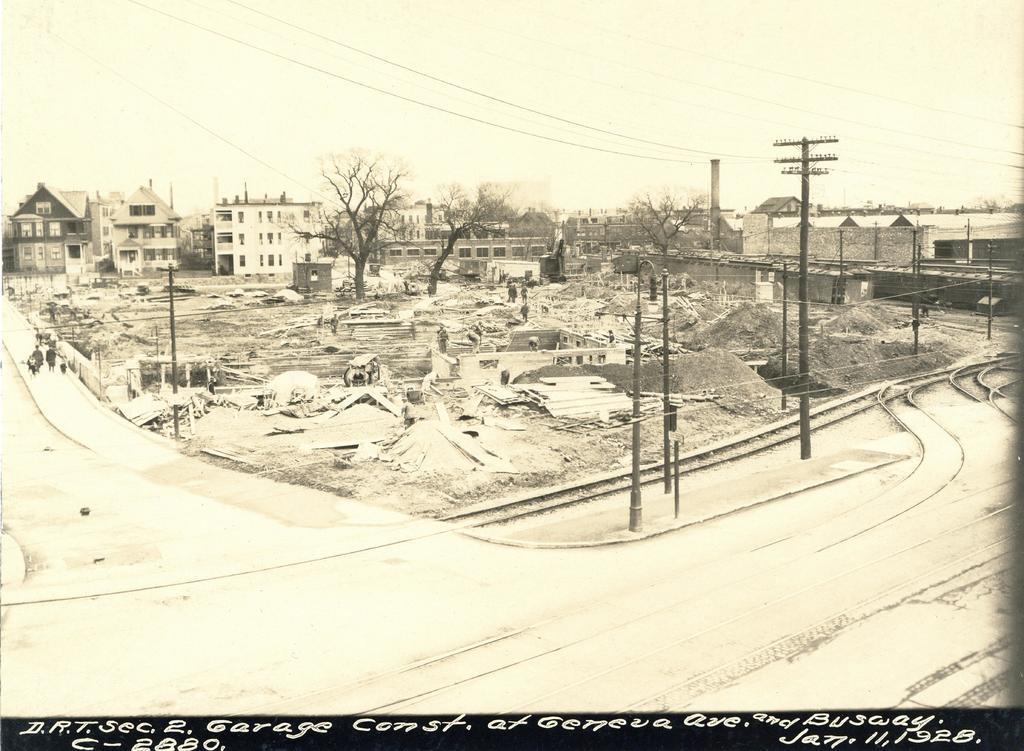Could you give a brief overview of what you see in this image? In the picture we can see a pencil sketch drawing of an area with railway tracks, roads and some people walking on it and houses, buildings with windows, doors and trees, sheds. 